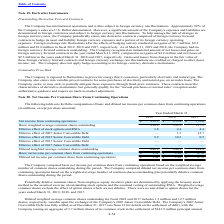From Microchip Technology's financial document, Which years does the table provide information for the computation of basic and diluted net income per common share from continuing operations? The document contains multiple relevant values: 2019, 2018, 2017. From the document: "2019 2018 2017 2019 2018 2017 2019 2018 2017..." Also, What was the Net income from continuing operations in 2017? According to the financial document, 170.6 (in millions). The relevant text states: "come from continuing operations $ 355.9 $ 255.4 $ 170.6..." Also, What was the Dilutive effect of stock options and RSUs in 2019? According to the financial document, 3.8 (in millions). The relevant text states: "Dilutive effect of stock options and RSUs 3.8 4.4 4.4..." Also, How many years did the Dilutive effect of stock options and RSUs exceed $4 million? Counting the relevant items in the document: 2018, 2017, I find 2 instances. The key data points involved are: 2017, 2018. Also, can you calculate: What was the change in Net income from continuing operations between 2017 and 2018? Based on the calculation: 255.4-170.6, the result is 84.8 (in millions). This is based on the information: "come from continuing operations $ 355.9 $ 255.4 $ 170.6 Net income from continuing operations $ 355.9 $ 255.4 $ 170.6..." The key data points involved are: 170.6, 255.4. Also, can you calculate: What was the percentage change in the Basic net income per common share from continuing operations between 2018 and 2019? To answer this question, I need to perform calculations using the financial data. The calculation is: (1.51-1.10)/1.10, which equals 37.27 (percentage). This is based on the information: "ome per common share from continuing operations $ 1.51 $ 1.10 $ 0.79 common share from continuing operations $ 1.51 $ 1.10 $ 0.79..." The key data points involved are: 1.10, 1.51. 